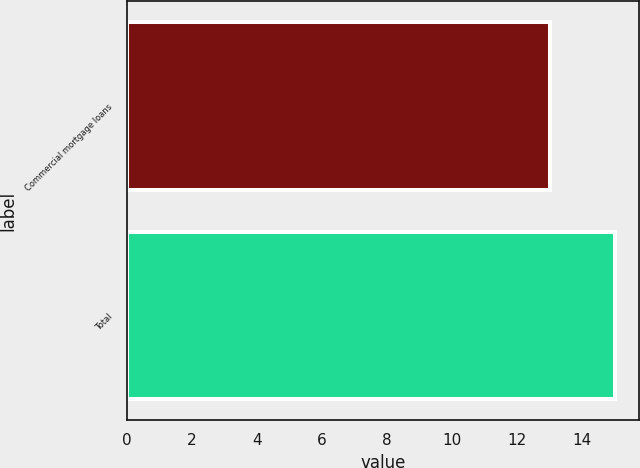<chart> <loc_0><loc_0><loc_500><loc_500><bar_chart><fcel>Commercial mortgage loans<fcel>Total<nl><fcel>13<fcel>15<nl></chart> 